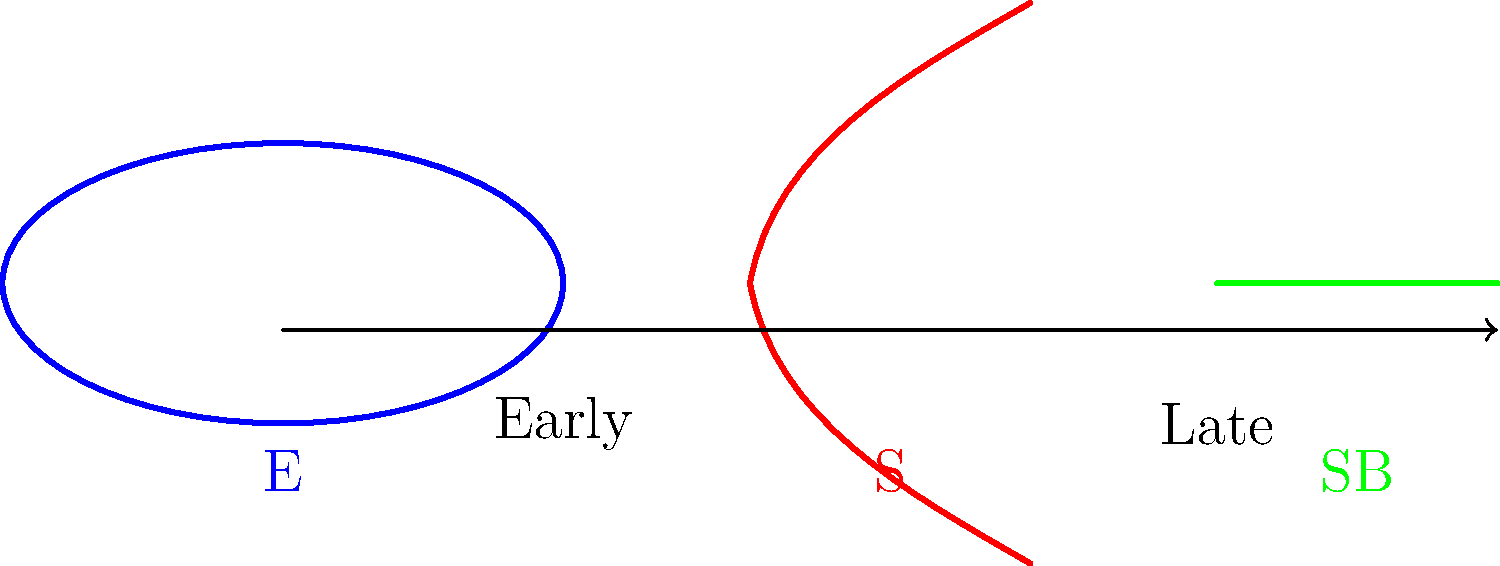In Hubble's tuning fork diagram for galaxy classification, what does the progression from left to right represent, and how are the main galaxy types arranged? To answer this question, let's break down Hubble's tuning fork diagram:

1. The diagram progresses from left to right, representing a transition from "early" to "late" type galaxies. This terminology is historical and does not refer to the actual age of the galaxies.

2. On the left side of the diagram, we have elliptical galaxies (E), represented by the blue ellipse.

3. Moving to the right, the diagram splits into two prongs, forming the "tuning fork" shape:
   a. The upper prong represents spiral galaxies (S), shown in red.
   b. The lower prong represents barred spiral galaxies (SB), indicated by the green bar.

4. Both spiral and barred spiral galaxies are considered "late" type galaxies.

5. The progression along each prong (from left to right) represents:
   a. For spiral galaxies: increasing prominence of spiral arms and decreasing size of the central bulge.
   b. For barred spiral galaxies: increasing prominence of both the bar and spiral arms.

6. Elliptical galaxies are classified from E0 (nearly spherical) to E7 (highly elongated), though this detail is not shown in the simplified diagram.

7. The arrangement of galaxy types in this diagram reflects a continuous sequence of morphological characteristics, not an evolutionary sequence.
Answer: Left to right: early to late types; Ellipticals on left, spirals and barred spirals on right prongs. 